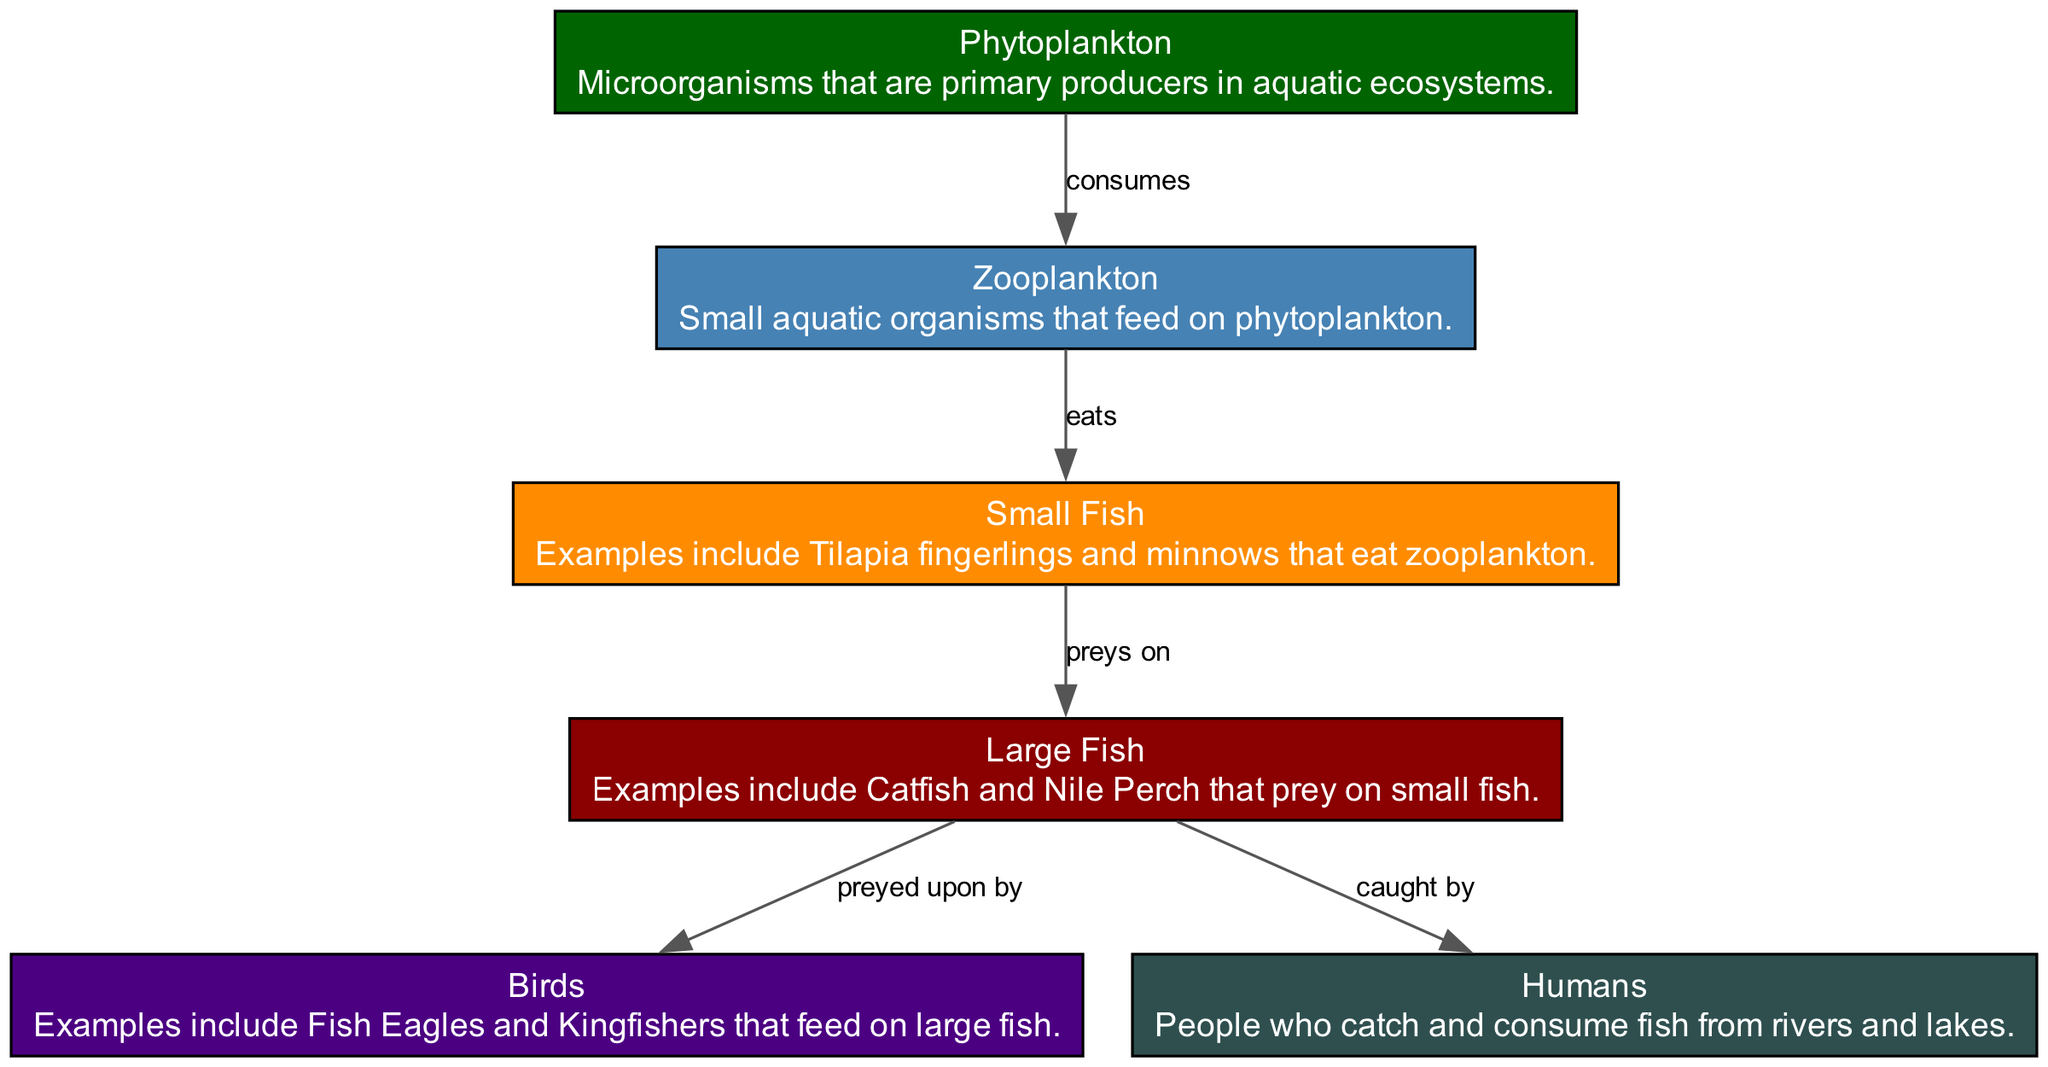What are the primary producers in the food chain? The diagram identifies "Phytoplankton" as the primary producers, which are the first step in the food chain, producing energy through photosynthesis and forming the basis for aquatic food webs.
Answer: Phytoplankton Which organisms are at the top of the food chain? "Birds" are represented as the apex predators in this diagram, as they are depicted at the highest level of the food chain, preying on large fish.
Answer: Birds How many nodes are there in the food chain? The diagram contains a total of six nodes representing different organisms, including producers and consumers, indicating a diverse food chain.
Answer: Six What do zooplankton feed on? According to the diagram, zooplankton primarily consume phytoplankton, which is established by the directional edge labeled "consumes" from phytoplankton to zooplankton.
Answer: Phytoplankton Who preys on large fish? The edge labeled "preyed upon by" connects large fish to birds, indicating that birds hunt large fish as part of their feeding behavior in the food chain.
Answer: Birds How many relationships are shown in the diagram? The diagram displays five edges that illustrate the various relationships between the organisms, thus showing how energy and nutrients flow through the food chain.
Answer: Five Which organisms are caught by humans according to the diagram? The diagram shows that "large fish" are the organisms caught by humans, depicted by the edge labeled "caught by" that connects large fish to humans.
Answer: Large fish What type of fish do small fish eat? The relationship illustrated in the diagram indicates that small fish feed on zooplankton, marking the flow of energy from one trophic level to the next.
Answer: Zooplankton What is the color associated with phytoplankton in the diagram? The diagram corresponds the color dark green to phytoplankton, representing its position in the ecosystem and denoting its role as a primary producer.
Answer: Dark green 